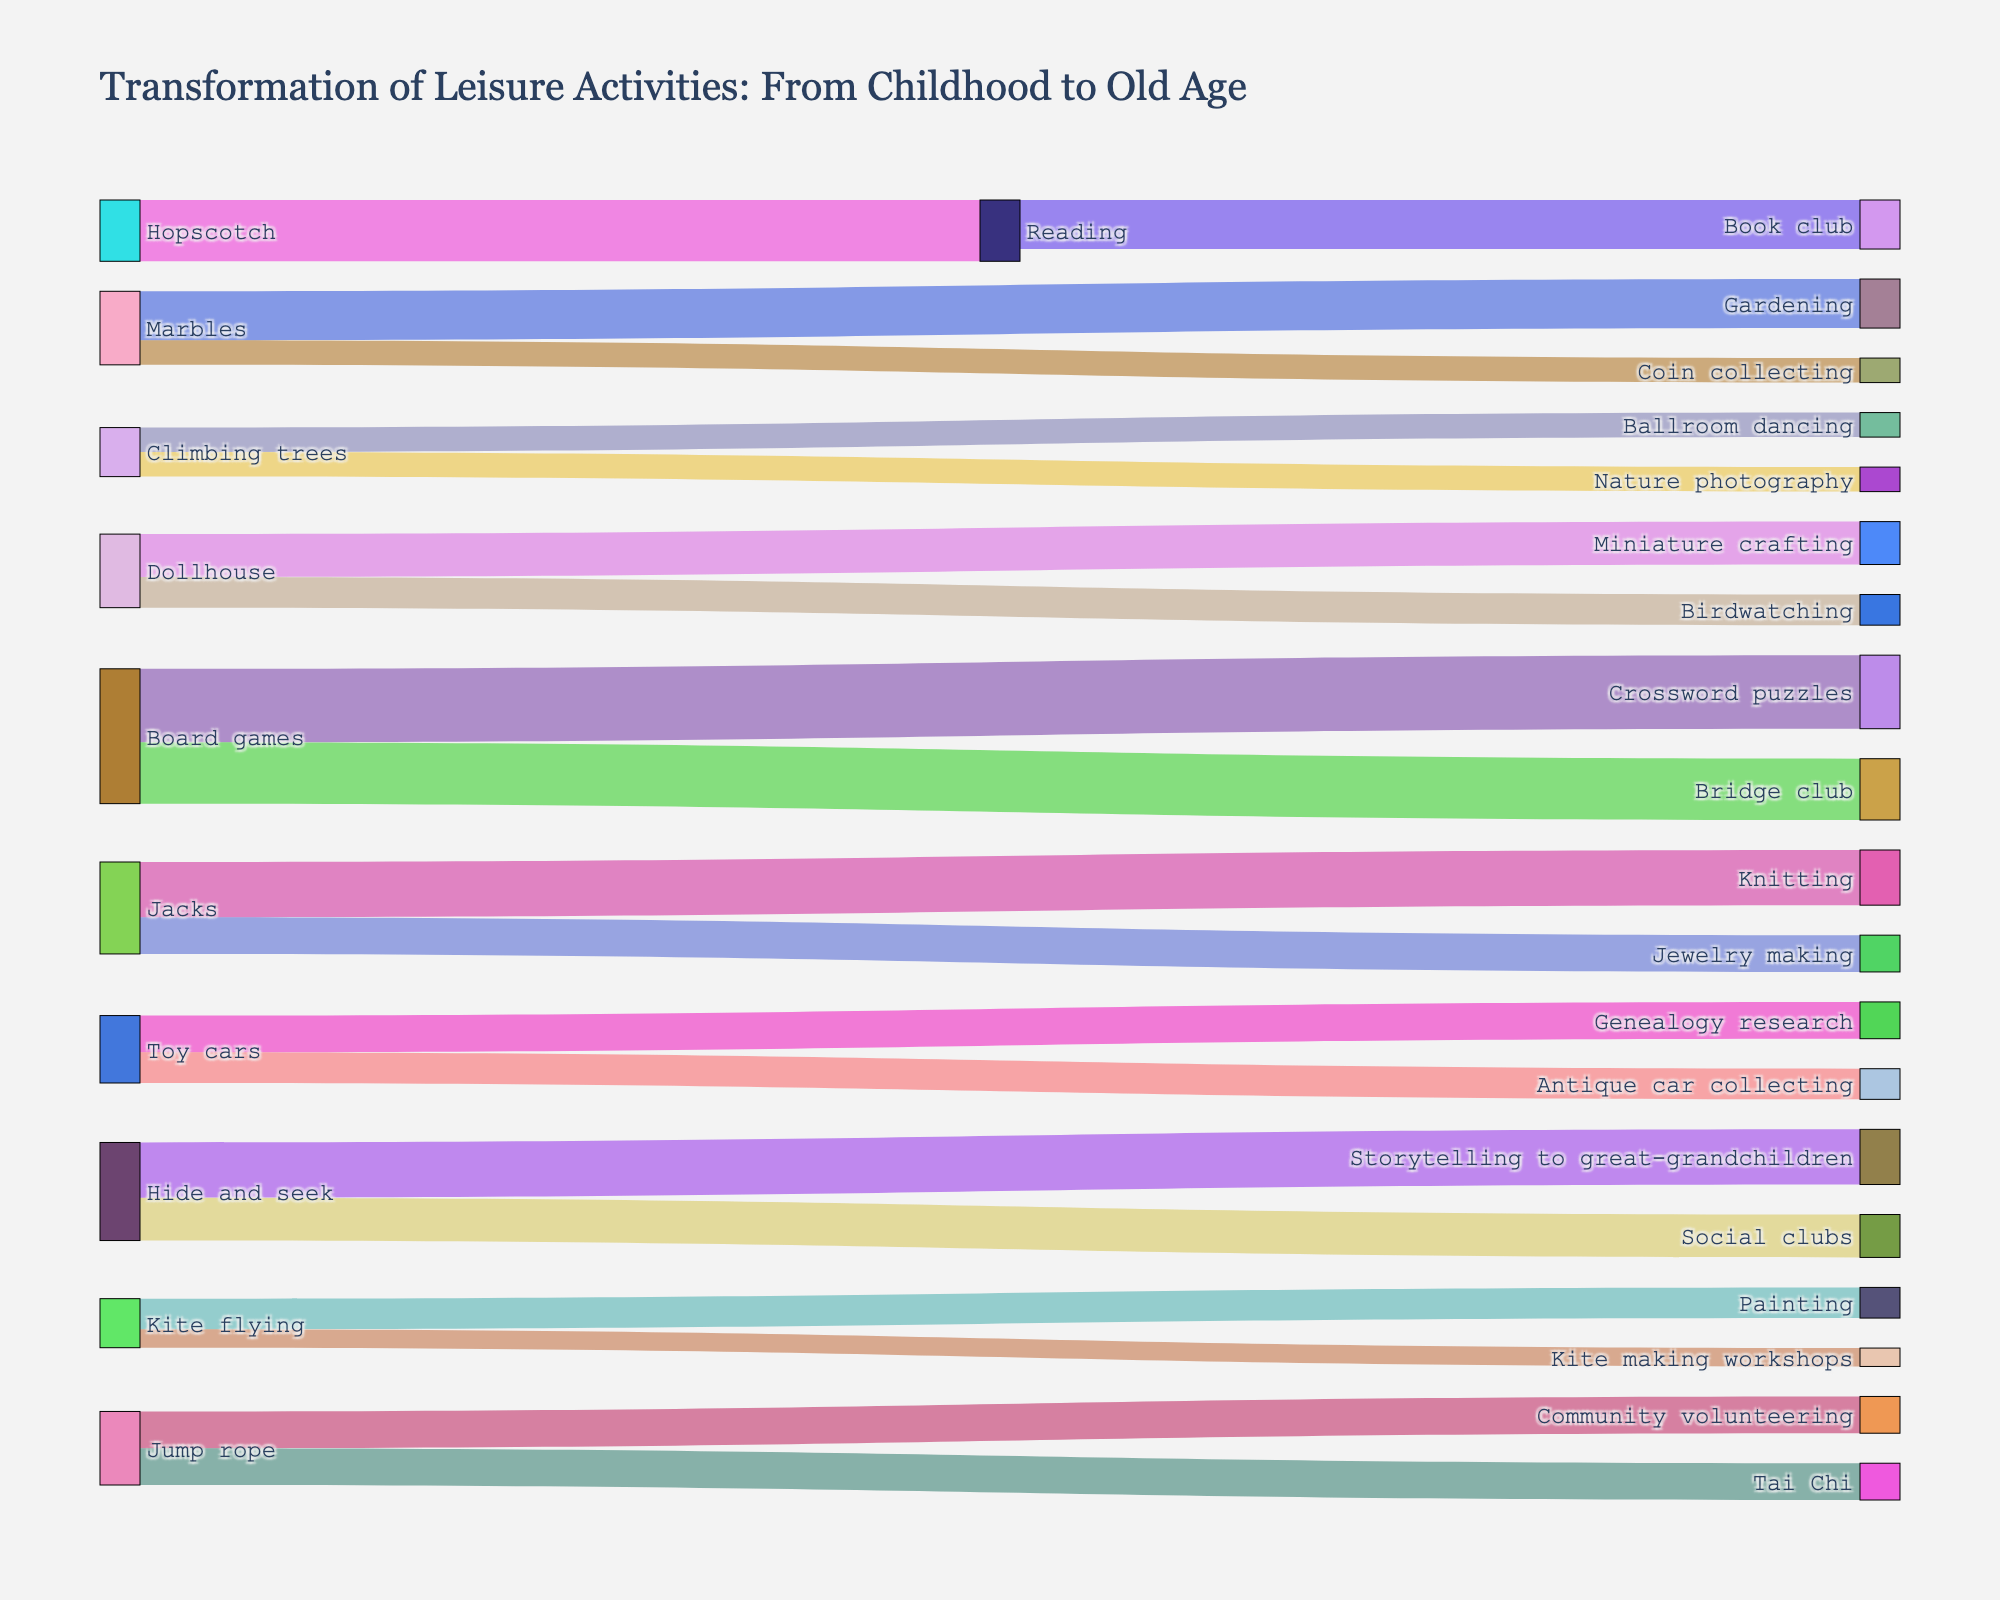What's the title of the figure? The title is mentioned at the top of the figure as text that describes the overall theme of the visualization.
Answer: "Transformation of Leisure Activities: From Childhood to Old Age" How many childhood activities are represented in the diagram? The childhood activities are the sources of the links in the Sankey diagram. By counting the unique source nodes, we can determine the number.
Answer: 10 Which activity has the highest transformation value? Look at the values associated with each source-target link and identify the link with the largest numeric value.
Answer: "Board games" to "Crossword puzzles" with a value of 12 How many target activities are there in total? Count all the unique target nodes in the Sankey diagram. These represent activities transformed in old age.
Answer: 13 What's the total value of transformations from "Jump rope"? Sum up all the values of the links that originate from "Jump rope".
Answer: 6 + 6 = 12 Which target activity is most related to reading in childhood? Identify the target activities directly connected to "Reading". Then select the one with the highest value.
Answer: "Book club" How many activities transition to social interactions in old age? Look for target activities involving social aspects, count how many source activities transition into these targets. Consider categories like "Community volunteering," "Social clubs," "Book club," etc.
Answer: 5 (Gardening, Community volunteering, Social clubs, Bridge club, Storytelling to grandchildren) Which childhood activity transitioned into "Genealogy research"? Check the source activities linking to the target node "Genealogy research".
Answer: "Toy cars" Between "Dollhouse" and "Climbing trees," which has more transformations into old age activities? Sum up the values of the links for both source activities and compare the totals.
Answer: "Dollhouse" with 12 (compared to "Climbing trees" with 8) Which activity has the fewest transformations and what is its old age equivalent? Identify the link with the smallest value and its corresponding activities.
Answer: "Kite flying" to "Kite making workshops" with a value of 3 